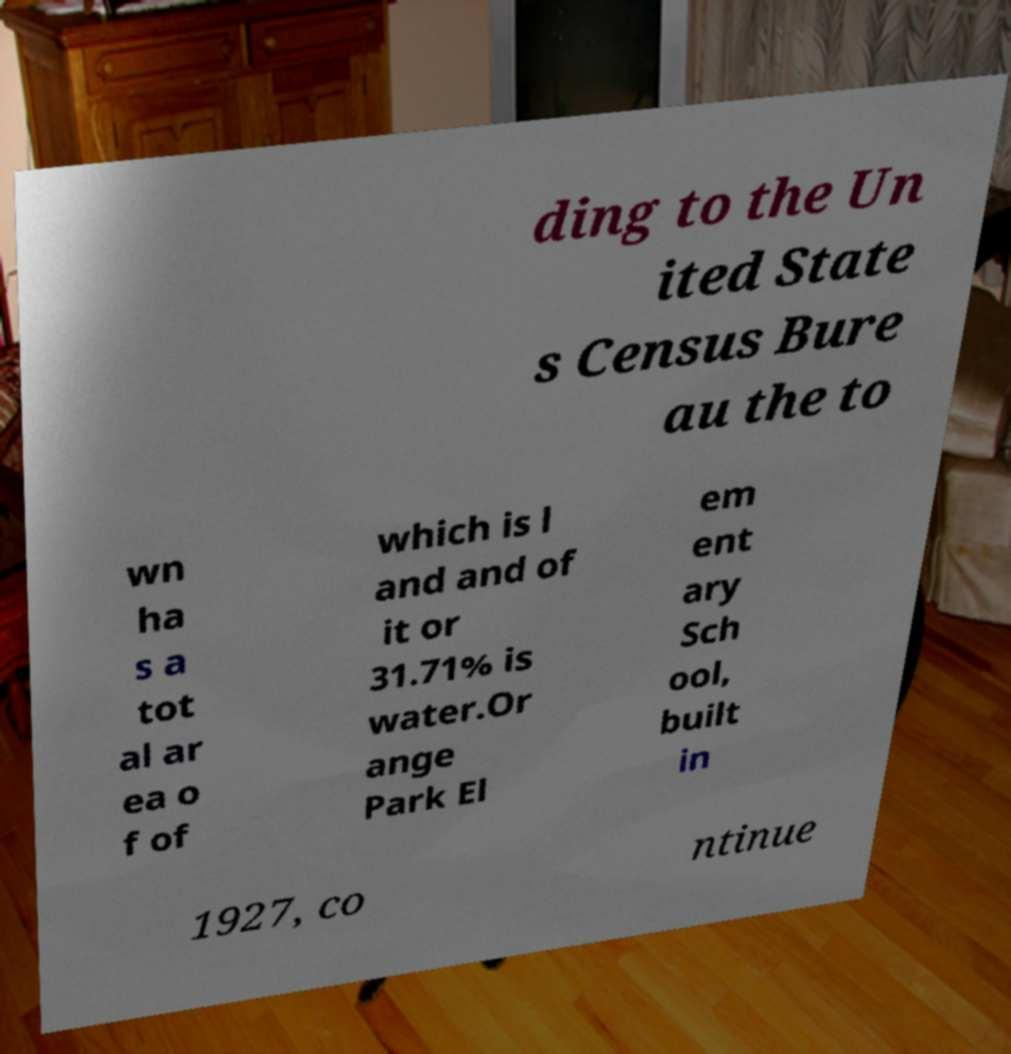Please identify and transcribe the text found in this image. ding to the Un ited State s Census Bure au the to wn ha s a tot al ar ea o f of which is l and and of it or 31.71% is water.Or ange Park El em ent ary Sch ool, built in 1927, co ntinue 